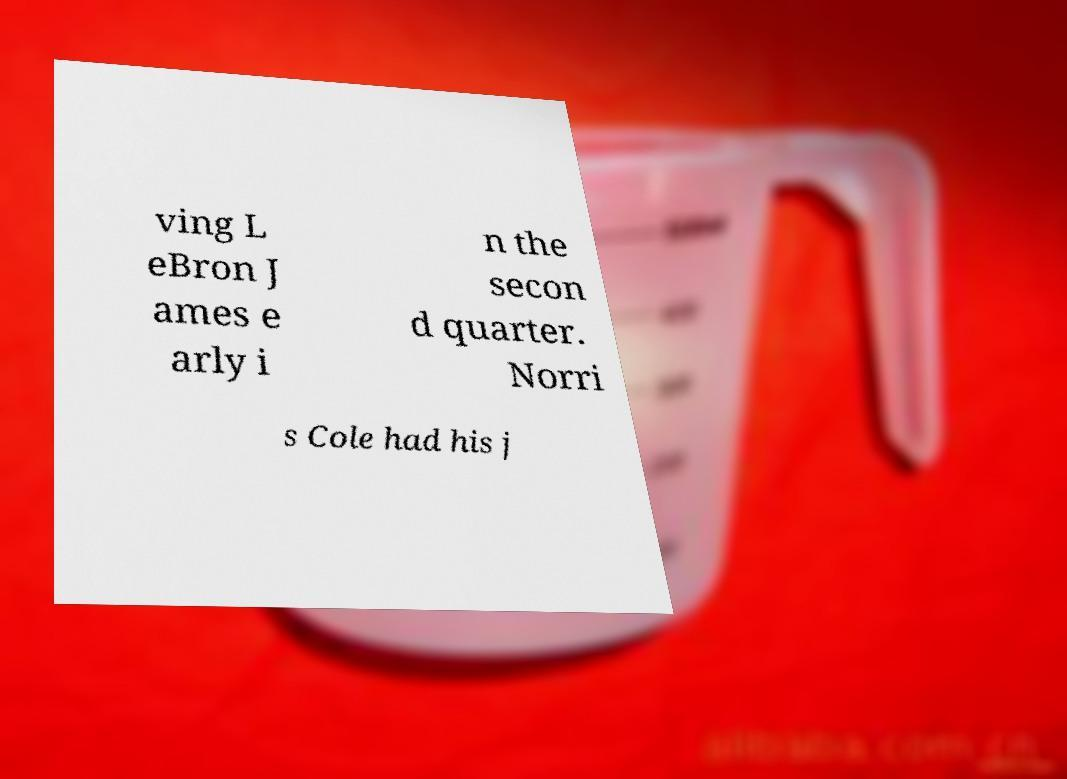There's text embedded in this image that I need extracted. Can you transcribe it verbatim? ving L eBron J ames e arly i n the secon d quarter. Norri s Cole had his j 